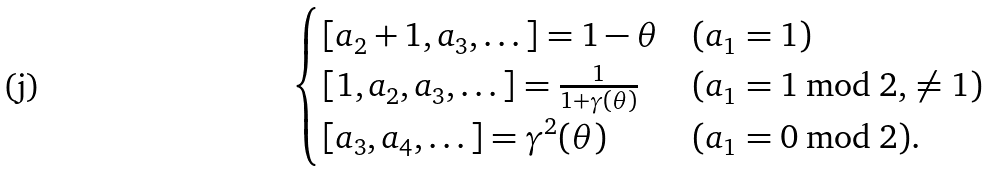<formula> <loc_0><loc_0><loc_500><loc_500>\begin{cases} [ a _ { 2 } + 1 , a _ { 3 } , \dots ] = 1 - \theta & ( a _ { 1 } = 1 ) \\ [ 1 , a _ { 2 } , a _ { 3 } , \dots ] = \frac { 1 } { 1 + \gamma ( \theta ) } & ( a _ { 1 } = 1 \bmod 2 , \, \neq 1 ) \\ [ a _ { 3 } , a _ { 4 } , \dots ] = \gamma ^ { 2 } ( \theta ) & ( a _ { 1 } = 0 \bmod 2 ) . \end{cases}</formula> 